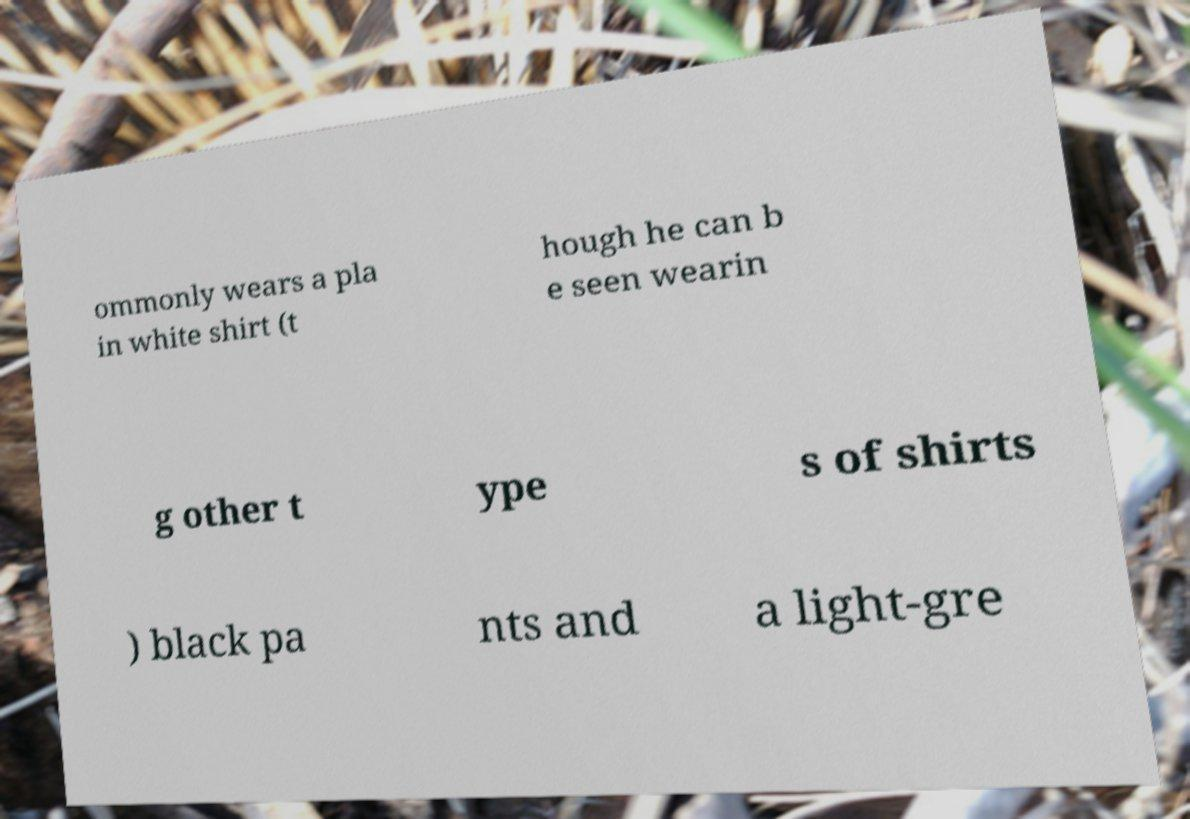Could you extract and type out the text from this image? ommonly wears a pla in white shirt (t hough he can b e seen wearin g other t ype s of shirts ) black pa nts and a light-gre 